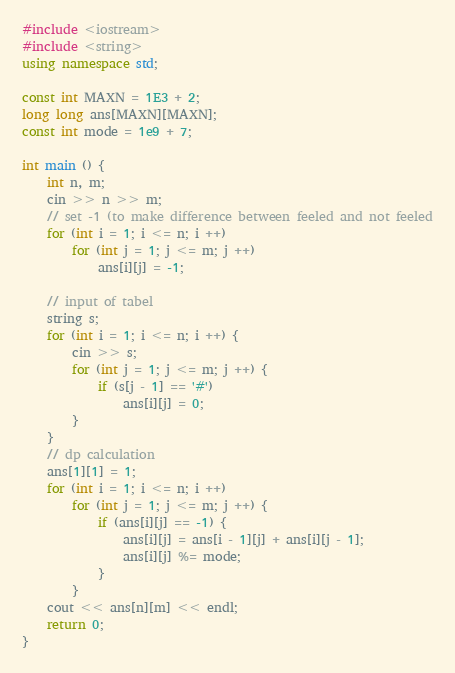<code> <loc_0><loc_0><loc_500><loc_500><_C++_>#include <iostream>
#include <string>
using namespace std;

const int MAXN = 1E3 + 2;
long long ans[MAXN][MAXN];
const int mode = 1e9 + 7;

int main () {
	int n, m;
	cin >> n >> m;
	// set -1 (to make difference between feeled and not feeled
	for (int i = 1; i <= n; i ++)
		for (int j = 1; j <= m; j ++)
			ans[i][j] = -1;
			
	// input of tabel
	string s;
	for (int i = 1; i <= n; i ++) {
		cin >> s;
		for (int j = 1; j <= m; j ++) {
			if (s[j - 1] == '#')
				ans[i][j] = 0;
		}
	}
	// dp calculation
	ans[1][1] = 1;
	for (int i = 1; i <= n; i ++)
		for (int j = 1; j <= m; j ++) {
			if (ans[i][j] == -1) {
				ans[i][j] = ans[i - 1][j] + ans[i][j - 1];
				ans[i][j] %= mode;
			}
		}
	cout << ans[n][m] << endl;
	return 0;
}
</code> 